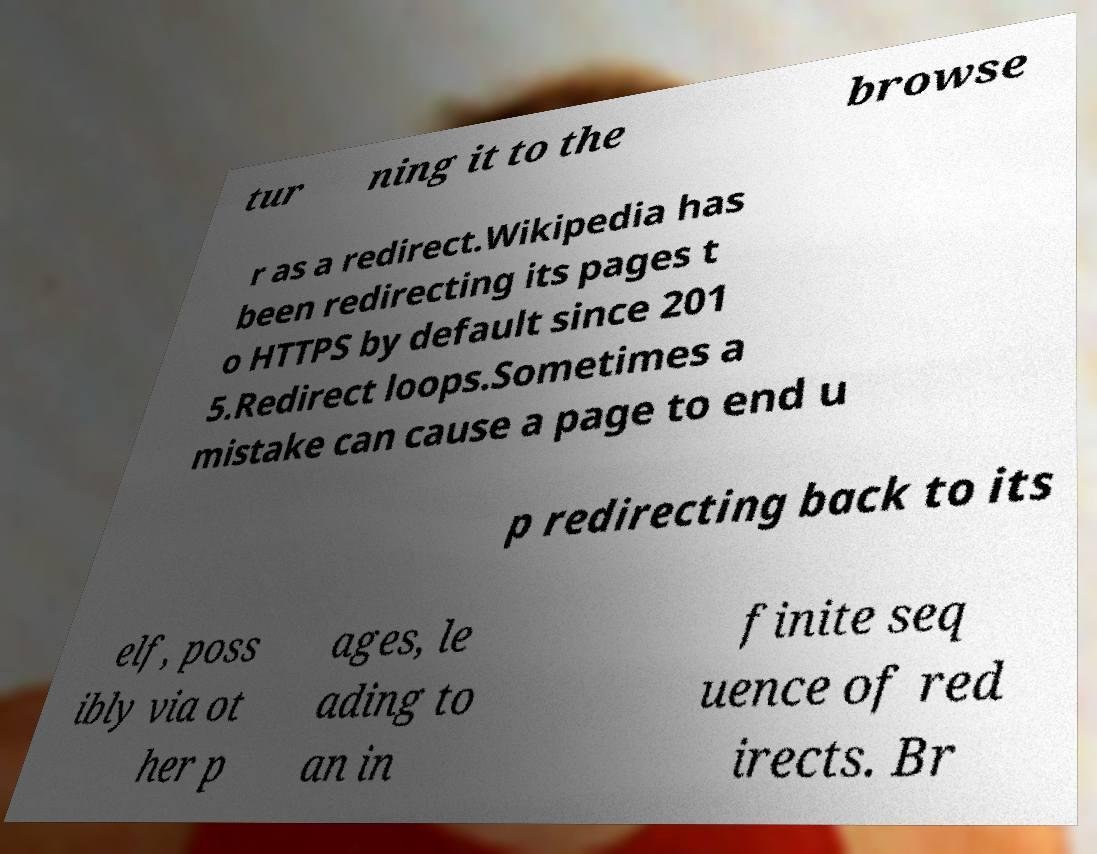Please identify and transcribe the text found in this image. tur ning it to the browse r as a redirect.Wikipedia has been redirecting its pages t o HTTPS by default since 201 5.Redirect loops.Sometimes a mistake can cause a page to end u p redirecting back to its elf, poss ibly via ot her p ages, le ading to an in finite seq uence of red irects. Br 